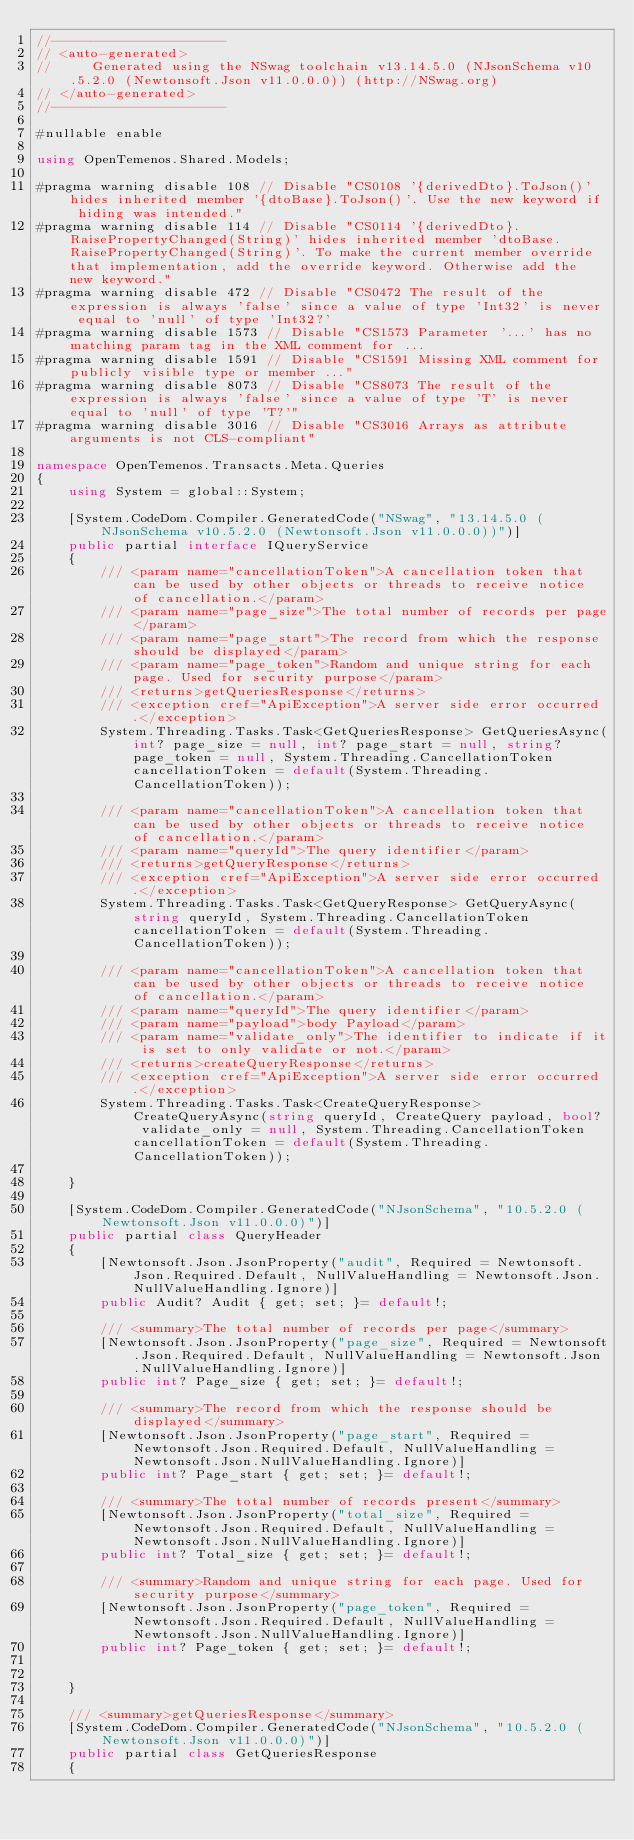Convert code to text. <code><loc_0><loc_0><loc_500><loc_500><_C#_>//----------------------
// <auto-generated>
//     Generated using the NSwag toolchain v13.14.5.0 (NJsonSchema v10.5.2.0 (Newtonsoft.Json v11.0.0.0)) (http://NSwag.org)
// </auto-generated>
//----------------------

#nullable enable

using OpenTemenos.Shared.Models;

#pragma warning disable 108 // Disable "CS0108 '{derivedDto}.ToJson()' hides inherited member '{dtoBase}.ToJson()'. Use the new keyword if hiding was intended."
#pragma warning disable 114 // Disable "CS0114 '{derivedDto}.RaisePropertyChanged(String)' hides inherited member 'dtoBase.RaisePropertyChanged(String)'. To make the current member override that implementation, add the override keyword. Otherwise add the new keyword."
#pragma warning disable 472 // Disable "CS0472 The result of the expression is always 'false' since a value of type 'Int32' is never equal to 'null' of type 'Int32?'
#pragma warning disable 1573 // Disable "CS1573 Parameter '...' has no matching param tag in the XML comment for ...
#pragma warning disable 1591 // Disable "CS1591 Missing XML comment for publicly visible type or member ..."
#pragma warning disable 8073 // Disable "CS8073 The result of the expression is always 'false' since a value of type 'T' is never equal to 'null' of type 'T?'"
#pragma warning disable 3016 // Disable "CS3016 Arrays as attribute arguments is not CLS-compliant"

namespace OpenTemenos.Transacts.Meta.Queries
{
    using System = global::System;

    [System.CodeDom.Compiler.GeneratedCode("NSwag", "13.14.5.0 (NJsonSchema v10.5.2.0 (Newtonsoft.Json v11.0.0.0))")]
    public partial interface IQueryService
    {
        /// <param name="cancellationToken">A cancellation token that can be used by other objects or threads to receive notice of cancellation.</param>
        /// <param name="page_size">The total number of records per page</param>
        /// <param name="page_start">The record from which the response should be displayed</param>
        /// <param name="page_token">Random and unique string for each page. Used for security purpose</param>
        /// <returns>getQueriesResponse</returns>
        /// <exception cref="ApiException">A server side error occurred.</exception>
        System.Threading.Tasks.Task<GetQueriesResponse> GetQueriesAsync(int? page_size = null, int? page_start = null, string? page_token = null, System.Threading.CancellationToken cancellationToken = default(System.Threading.CancellationToken));
    
        /// <param name="cancellationToken">A cancellation token that can be used by other objects or threads to receive notice of cancellation.</param>
        /// <param name="queryId">The query identifier</param>
        /// <returns>getQueryResponse</returns>
        /// <exception cref="ApiException">A server side error occurred.</exception>
        System.Threading.Tasks.Task<GetQueryResponse> GetQueryAsync(string queryId, System.Threading.CancellationToken cancellationToken = default(System.Threading.CancellationToken));
    
        /// <param name="cancellationToken">A cancellation token that can be used by other objects or threads to receive notice of cancellation.</param>
        /// <param name="queryId">The query identifier</param>
        /// <param name="payload">body Payload</param>
        /// <param name="validate_only">The identifier to indicate if it is set to only validate or not.</param>
        /// <returns>createQueryResponse</returns>
        /// <exception cref="ApiException">A server side error occurred.</exception>
        System.Threading.Tasks.Task<CreateQueryResponse> CreateQueryAsync(string queryId, CreateQuery payload, bool? validate_only = null, System.Threading.CancellationToken cancellationToken = default(System.Threading.CancellationToken));
    
    }

    [System.CodeDom.Compiler.GeneratedCode("NJsonSchema", "10.5.2.0 (Newtonsoft.Json v11.0.0.0)")]
    public partial class QueryHeader 
    {
        [Newtonsoft.Json.JsonProperty("audit", Required = Newtonsoft.Json.Required.Default, NullValueHandling = Newtonsoft.Json.NullValueHandling.Ignore)]
        public Audit? Audit { get; set; }= default!;
    
        /// <summary>The total number of records per page</summary>
        [Newtonsoft.Json.JsonProperty("page_size", Required = Newtonsoft.Json.Required.Default, NullValueHandling = Newtonsoft.Json.NullValueHandling.Ignore)]
        public int? Page_size { get; set; }= default!;
    
        /// <summary>The record from which the response should be displayed</summary>
        [Newtonsoft.Json.JsonProperty("page_start", Required = Newtonsoft.Json.Required.Default, NullValueHandling = Newtonsoft.Json.NullValueHandling.Ignore)]
        public int? Page_start { get; set; }= default!;
    
        /// <summary>The total number of records present</summary>
        [Newtonsoft.Json.JsonProperty("total_size", Required = Newtonsoft.Json.Required.Default, NullValueHandling = Newtonsoft.Json.NullValueHandling.Ignore)]
        public int? Total_size { get; set; }= default!;
    
        /// <summary>Random and unique string for each page. Used for security purpose</summary>
        [Newtonsoft.Json.JsonProperty("page_token", Required = Newtonsoft.Json.Required.Default, NullValueHandling = Newtonsoft.Json.NullValueHandling.Ignore)]
        public int? Page_token { get; set; }= default!;
    
    
    }
    
    /// <summary>getQueriesResponse</summary>
    [System.CodeDom.Compiler.GeneratedCode("NJsonSchema", "10.5.2.0 (Newtonsoft.Json v11.0.0.0)")]
    public partial class GetQueriesResponse 
    {</code> 